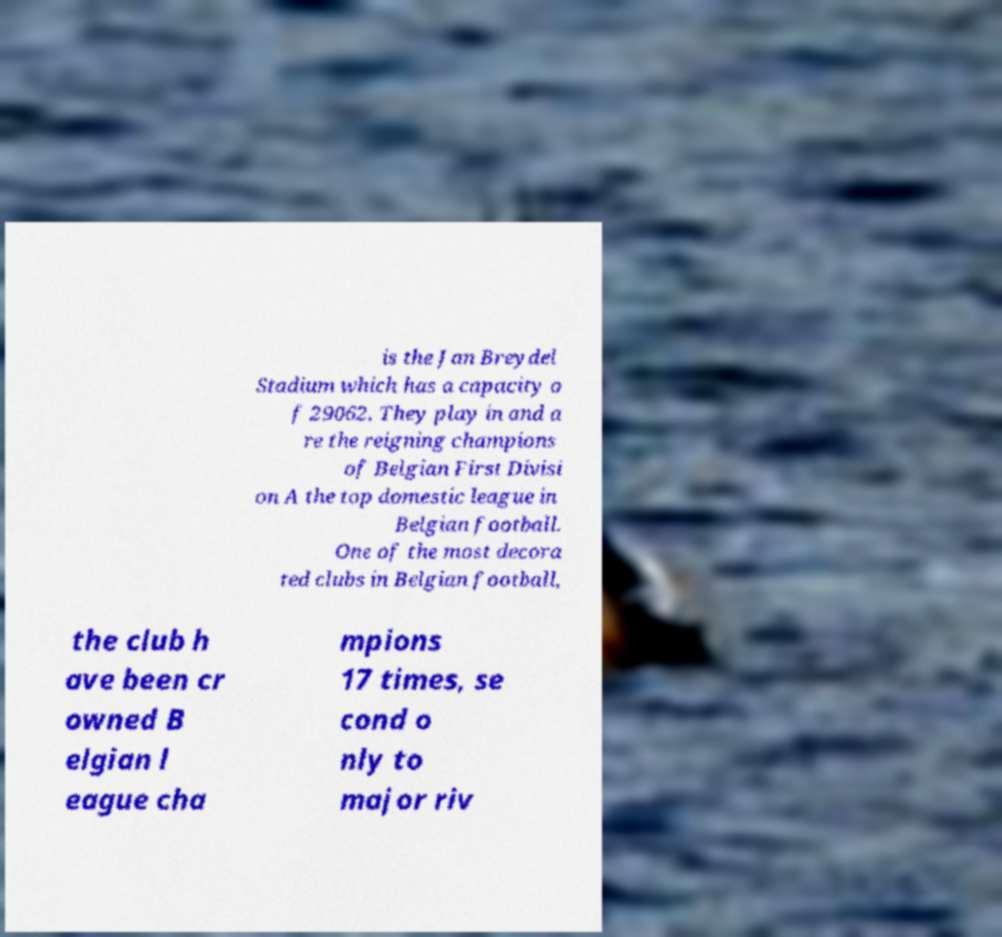Could you extract and type out the text from this image? is the Jan Breydel Stadium which has a capacity o f 29062. They play in and a re the reigning champions of Belgian First Divisi on A the top domestic league in Belgian football. One of the most decora ted clubs in Belgian football, the club h ave been cr owned B elgian l eague cha mpions 17 times, se cond o nly to major riv 